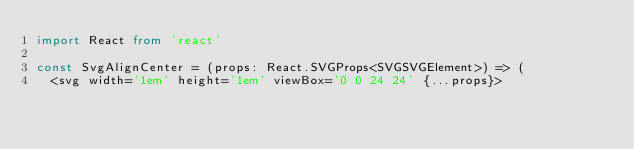<code> <loc_0><loc_0><loc_500><loc_500><_TypeScript_>import React from 'react'

const SvgAlignCenter = (props: React.SVGProps<SVGSVGElement>) => (
  <svg width='1em' height='1em' viewBox='0 0 24 24' {...props}></code> 